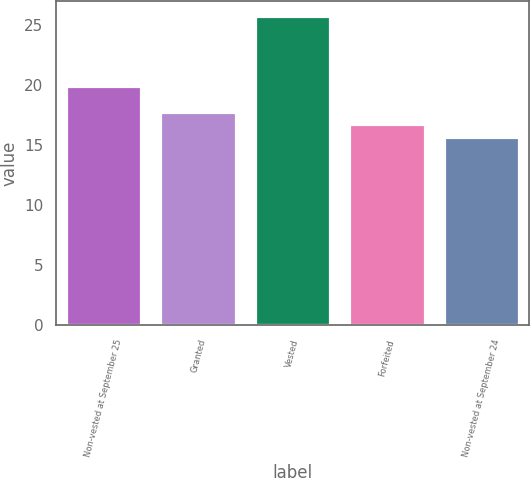Convert chart to OTSL. <chart><loc_0><loc_0><loc_500><loc_500><bar_chart><fcel>Non-vested at September 25<fcel>Granted<fcel>Vested<fcel>Forfeited<fcel>Non-vested at September 24<nl><fcel>19.9<fcel>17.75<fcel>25.76<fcel>16.74<fcel>15.67<nl></chart> 